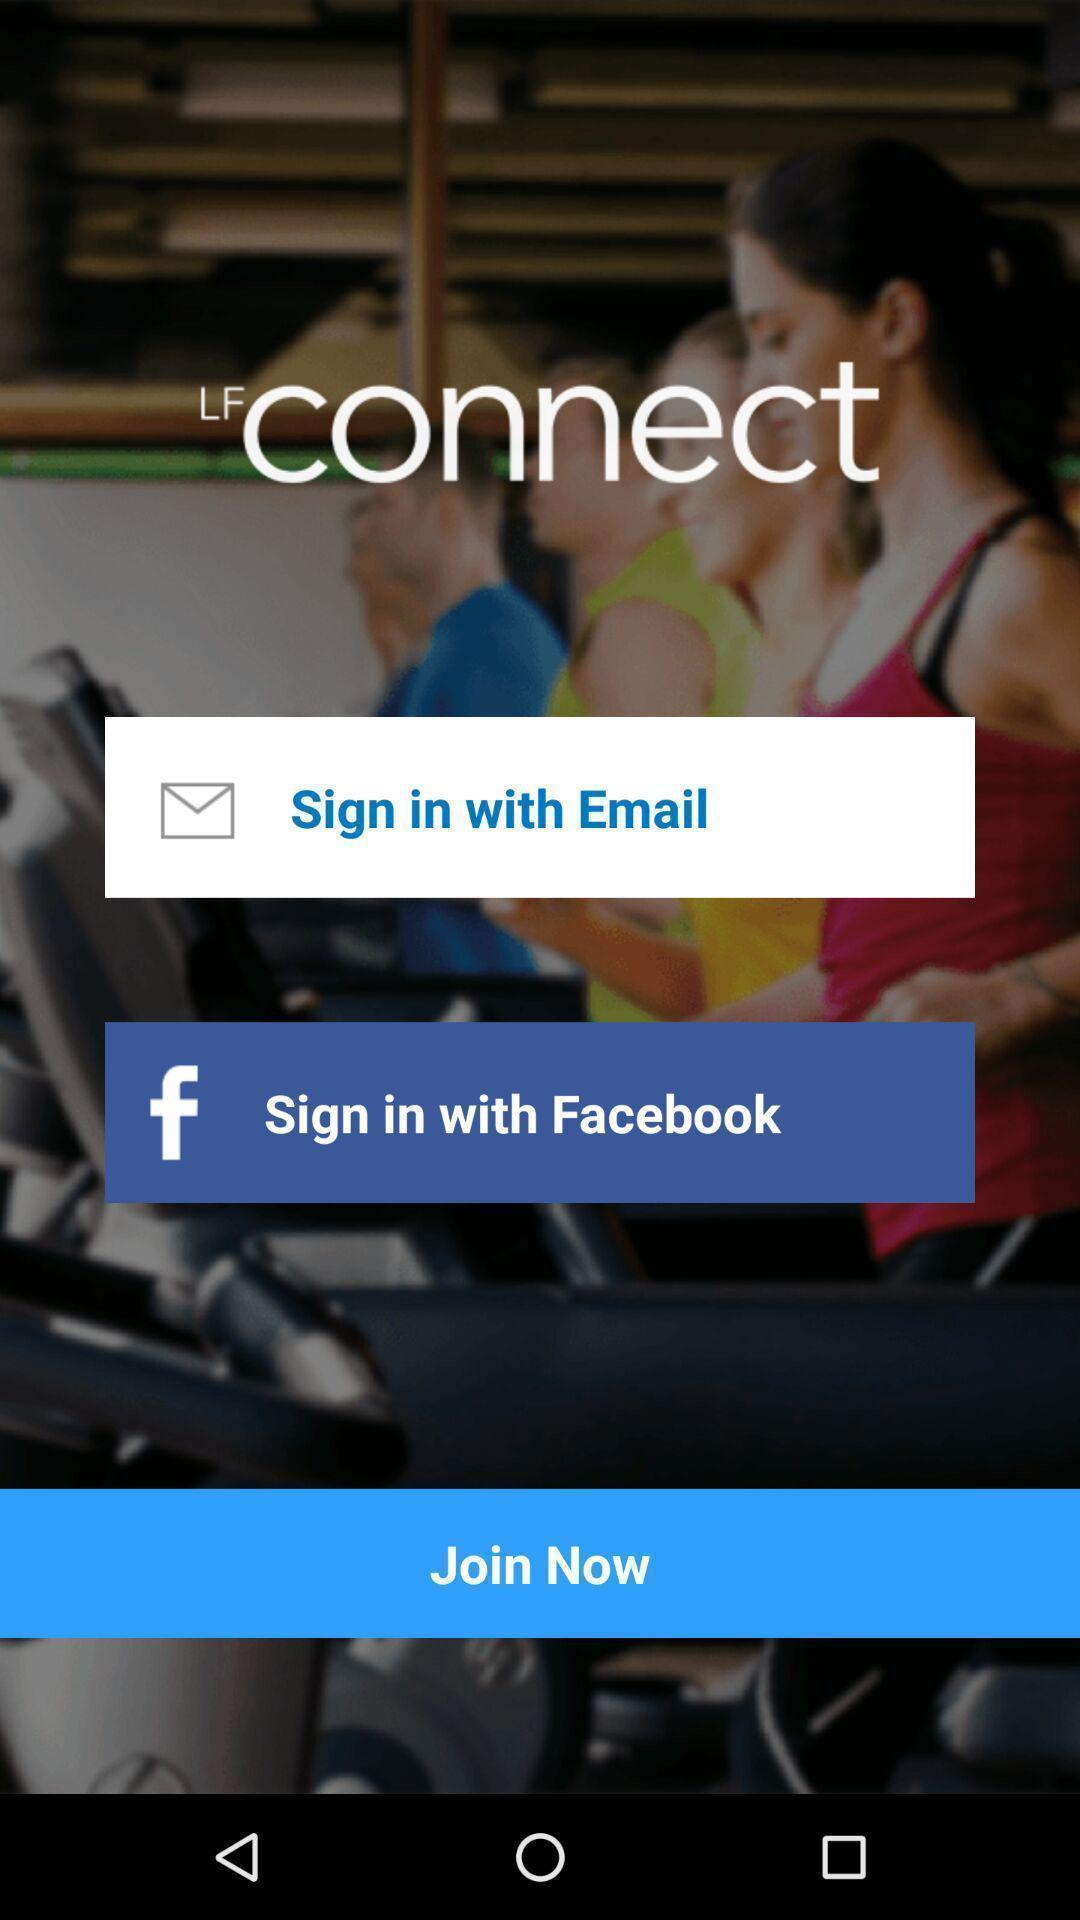Tell me what you see in this picture. Welcome page of a workout tracker application. 